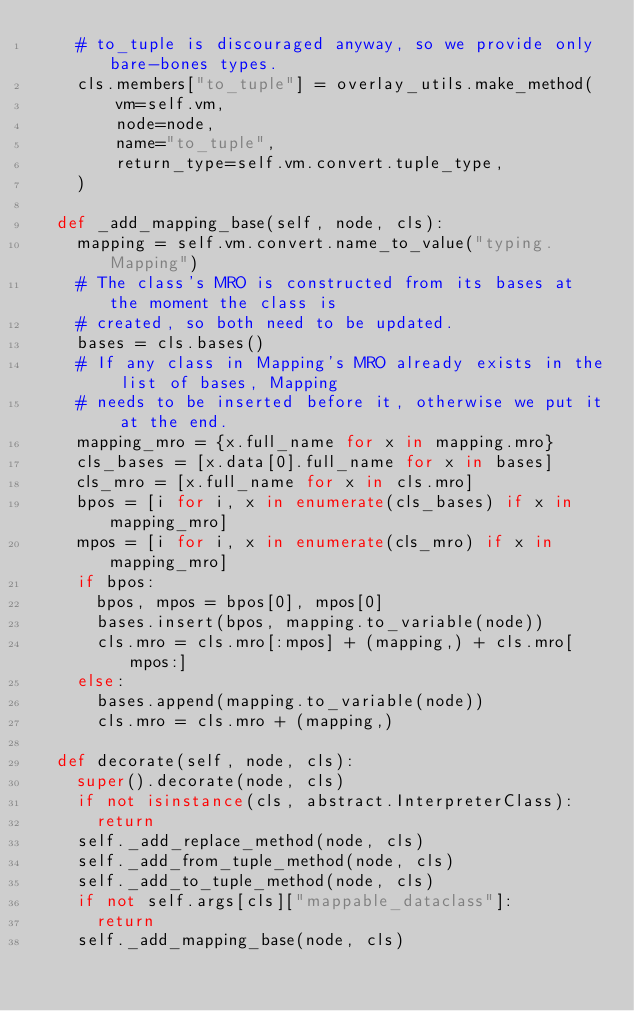Convert code to text. <code><loc_0><loc_0><loc_500><loc_500><_Python_>    # to_tuple is discouraged anyway, so we provide only bare-bones types.
    cls.members["to_tuple"] = overlay_utils.make_method(
        vm=self.vm,
        node=node,
        name="to_tuple",
        return_type=self.vm.convert.tuple_type,
    )

  def _add_mapping_base(self, node, cls):
    mapping = self.vm.convert.name_to_value("typing.Mapping")
    # The class's MRO is constructed from its bases at the moment the class is
    # created, so both need to be updated.
    bases = cls.bases()
    # If any class in Mapping's MRO already exists in the list of bases, Mapping
    # needs to be inserted before it, otherwise we put it at the end.
    mapping_mro = {x.full_name for x in mapping.mro}
    cls_bases = [x.data[0].full_name for x in bases]
    cls_mro = [x.full_name for x in cls.mro]
    bpos = [i for i, x in enumerate(cls_bases) if x in mapping_mro]
    mpos = [i for i, x in enumerate(cls_mro) if x in mapping_mro]
    if bpos:
      bpos, mpos = bpos[0], mpos[0]
      bases.insert(bpos, mapping.to_variable(node))
      cls.mro = cls.mro[:mpos] + (mapping,) + cls.mro[mpos:]
    else:
      bases.append(mapping.to_variable(node))
      cls.mro = cls.mro + (mapping,)

  def decorate(self, node, cls):
    super().decorate(node, cls)
    if not isinstance(cls, abstract.InterpreterClass):
      return
    self._add_replace_method(node, cls)
    self._add_from_tuple_method(node, cls)
    self._add_to_tuple_method(node, cls)
    if not self.args[cls]["mappable_dataclass"]:
      return
    self._add_mapping_base(node, cls)
</code> 